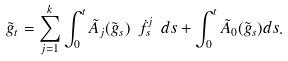Convert formula to latex. <formula><loc_0><loc_0><loc_500><loc_500>\tilde { g } _ { t } = \sum _ { j = 1 } ^ { k } \int _ { 0 } ^ { t } \tilde { A } _ { j } ( \tilde { g } _ { s } ) \ \dot { f } ^ { j } _ { s } \ d s + \int _ { 0 } ^ { t } \tilde { A } _ { 0 } ( \tilde { g } _ { s } ) d s .</formula> 